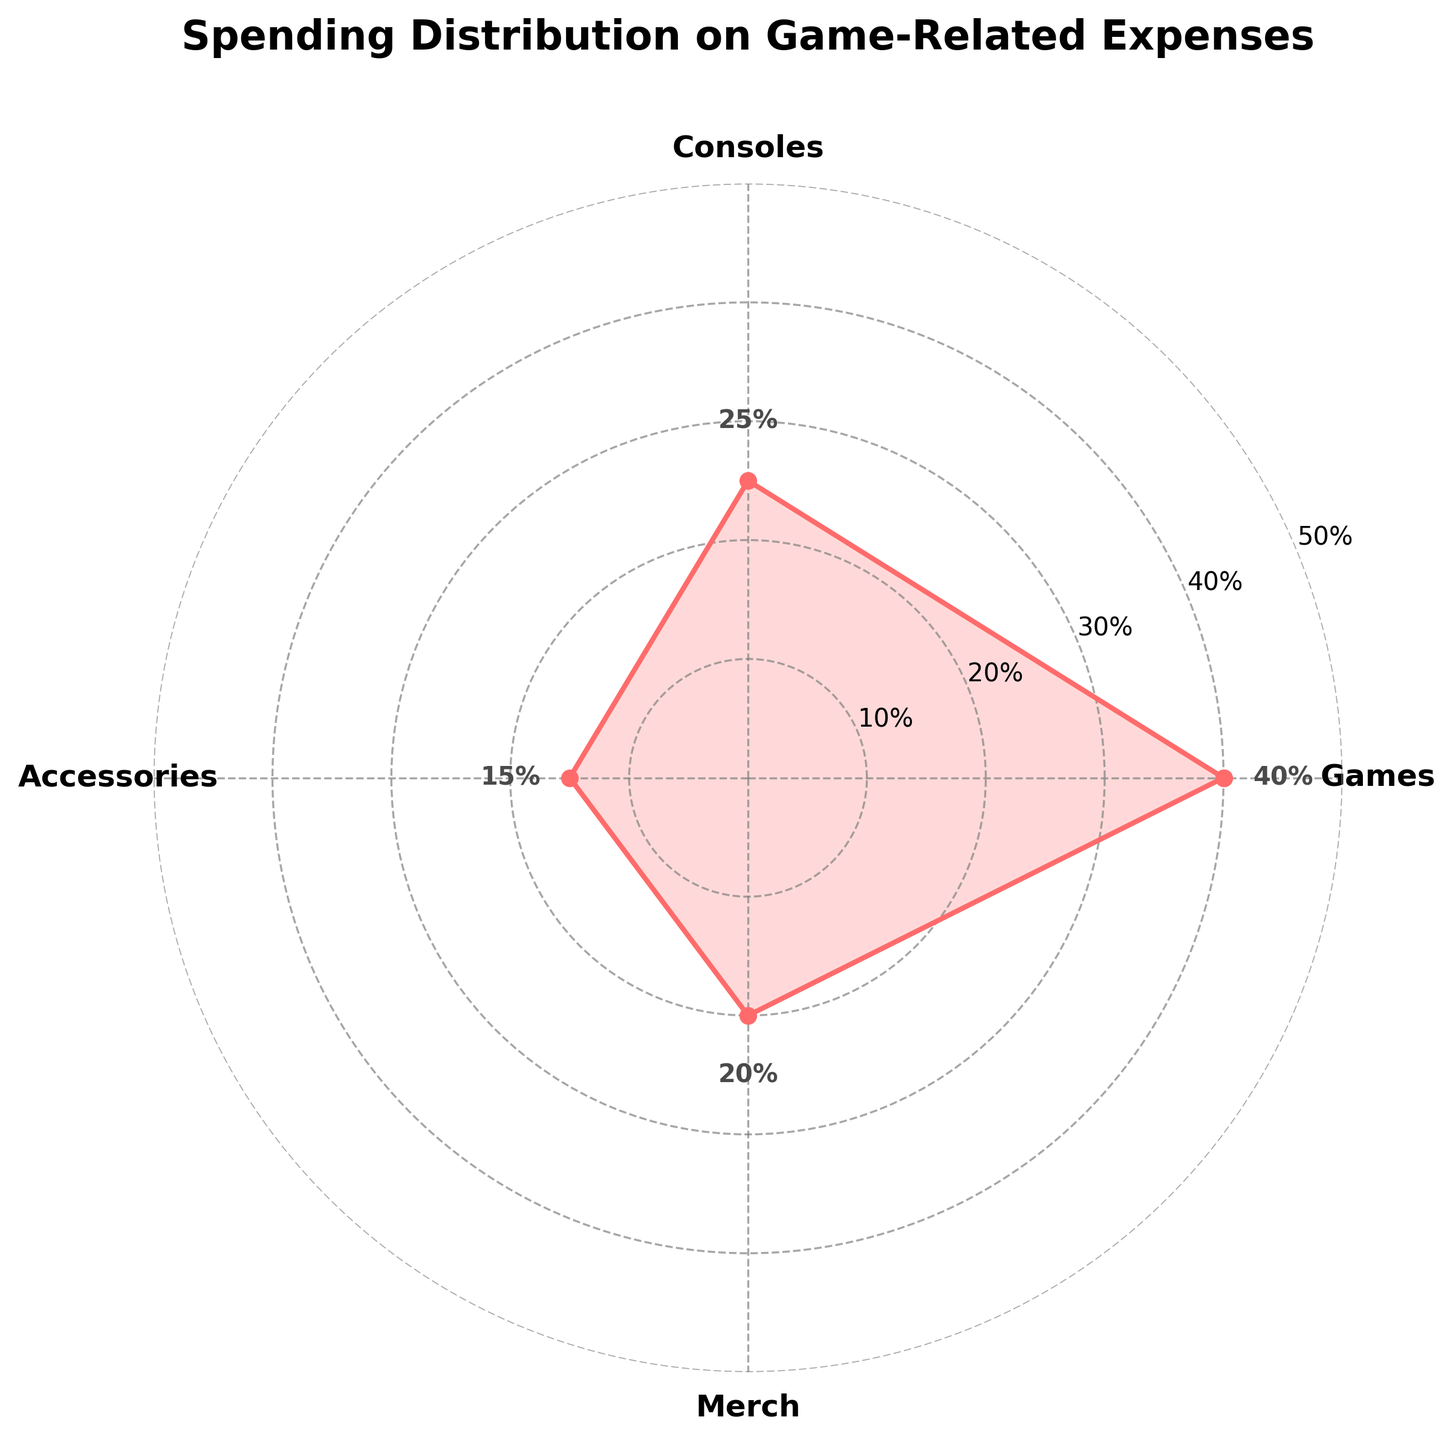What is the title of the radar chart? The title of the radar chart is displayed at the top and it states what the chart is about. It is "Spending Distribution on Game-Related Expenses".
Answer: Spending Distribution on Game-Related Expenses What percentage of spending is allocated to Games? The radar chart has labels and values marked along the categories. For Games, the value shown is 40%.
Answer: 40% Which category has the lowest percentage of spending? By examining the values for each category, we see that Accessories has the lowest percentage at 15%.
Answer: Accessories What is the difference in percentage spending between Games and Merch? Games have a spending of 40% and Merch has a spending of 20%. The difference is 40% - 20% = 20%.
Answer: 20% What is the average percentage spent on Consoles and Accessories? Adding the percentages for Consoles (25%) and Accessories (15%) gives 40%. Dividing by 2 gives the average: 40% / 2 = 20%.
Answer: 20% Is there an even or odd number of categories? The radar chart has 4 categories: Games, Consoles, Accessories, and Merch. Since 4 is an even number, the number of categories is even.
Answer: Even How much more is spent on Games compared to Consoles? Games have a percentage of 40% and Consoles have 25%. The difference is 40% - 25% = 15%.
Answer: 15% Which category has the second highest percentage of spending? By ordering the values, Games is the highest at 40%, and Merch is second highest at 20%.
Answer: Merch What is the total percentage of spending across all categories? Summing all the category percentages: 40% (Games) + 25% (Consoles) + 15% (Accessories) + 20% (Merch) gives a total of 100%.
Answer: 100% What pattern do the angles form in the radar chart? The radar chart has 4 categories, and the angles are equidistant from each other, each forming a 90-degree angle (360 degrees / 4 categories).
Answer: Equidistant 